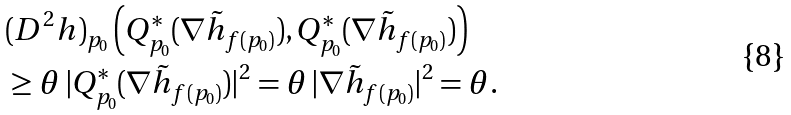<formula> <loc_0><loc_0><loc_500><loc_500>& ( D ^ { 2 } h ) _ { p _ { 0 } } \left ( Q _ { p _ { 0 } } ^ { * } ( \nabla \tilde { h } _ { f ( p _ { 0 } ) } ) , Q _ { p _ { 0 } } ^ { * } ( \nabla \tilde { h } _ { f ( p _ { 0 } ) } ) \right ) \\ & \geq \theta \, | Q _ { p _ { 0 } } ^ { * } ( \nabla \tilde { h } _ { f ( p _ { 0 } ) } ) | ^ { 2 } = \theta \, | \nabla \tilde { h } _ { f ( p _ { 0 } ) } | ^ { 2 } = \theta .</formula> 